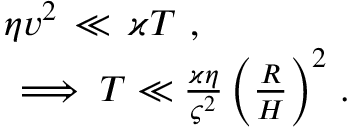<formula> <loc_0><loc_0><loc_500><loc_500>\begin{array} { r } { \eta v ^ { 2 } \, \ll \, \varkappa T \ , \ \quad } \\ { \implies T \ll \frac { \varkappa \eta } { \varsigma ^ { 2 } } \, \left ( \frac { R } { H } \right ) ^ { 2 } \ . \ } \end{array}</formula> 